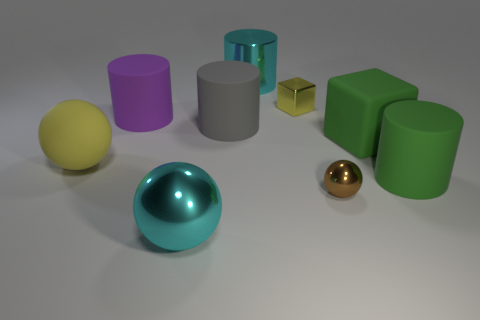The large rubber thing that is the same shape as the small brown thing is what color? The large rubber object, which shares the same spherical shape as the small brown sphere, is a vibrant shade of yellow. This bright color can provide a striking contrast to the variety of other hued objects present in the scene. 